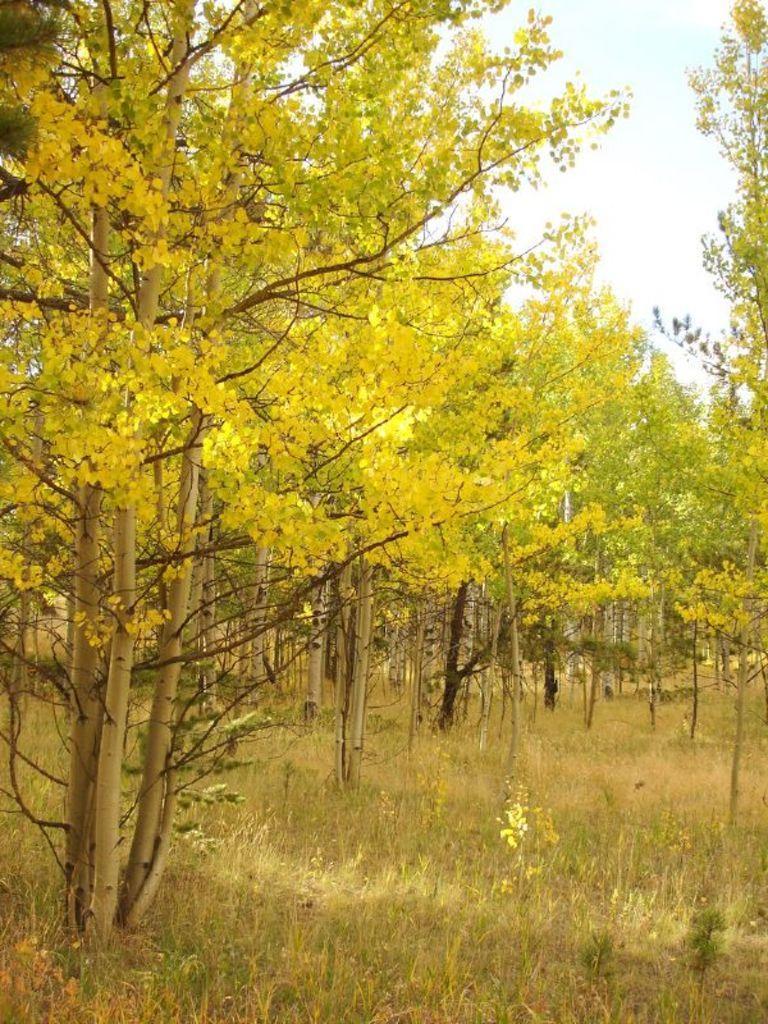Please provide a concise description of this image. In this image we can see there are some trees, grass and in the background there is a sky. 